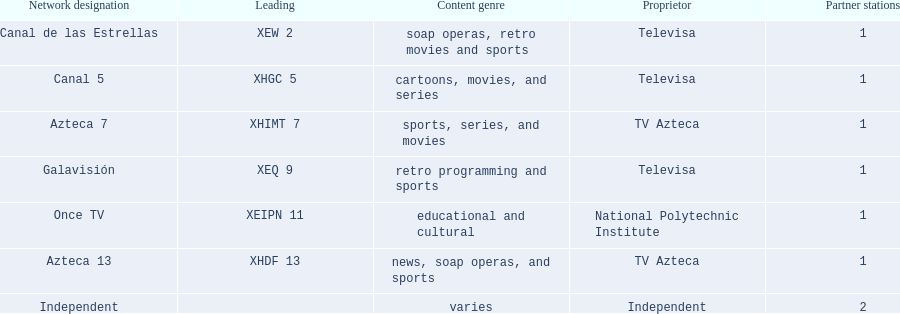How many networks does tv azteca own? 2. 